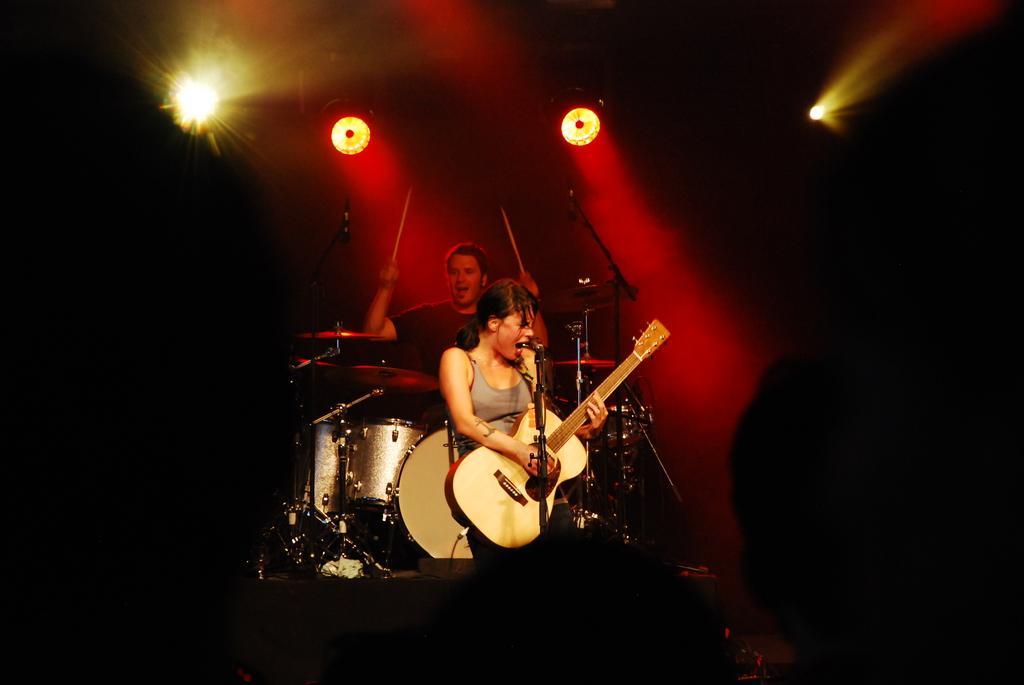Please provide a concise description of this image. Here we can see a woman standing and singing, and holding guitar in her hands, and at back a person is holding sticks in his hands and playing musical drums, and here are lights. 